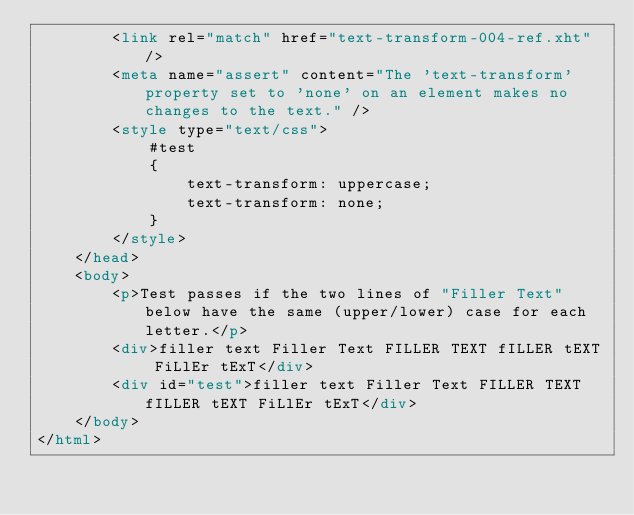<code> <loc_0><loc_0><loc_500><loc_500><_HTML_>        <link rel="match" href="text-transform-004-ref.xht"/>
        <meta name="assert" content="The 'text-transform' property set to 'none' on an element makes no changes to the text." />
        <style type="text/css">
            #test
            {
                text-transform: uppercase;
                text-transform: none;
            }
        </style>
    </head>
    <body>
        <p>Test passes if the two lines of "Filler Text" below have the same (upper/lower) case for each letter.</p>
        <div>filler text Filler Text FILLER TEXT fILLER tEXT FiLlEr tExT</div>
        <div id="test">filler text Filler Text FILLER TEXT fILLER tEXT FiLlEr tExT</div>
    </body>
</html>
</code> 